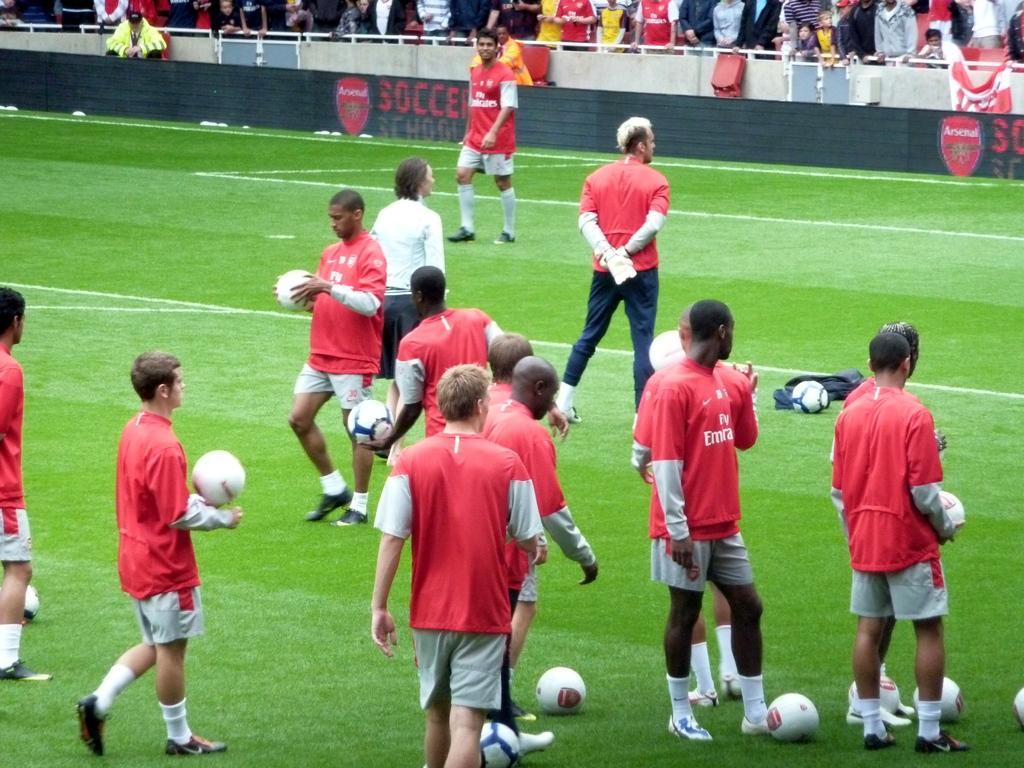How would you summarize this image in a sentence or two? this is play ground and there are the people walking and standing on the play ground and holding a ball on their hands and there are audience stand near to the fence. and there is a text written on the fence.. 